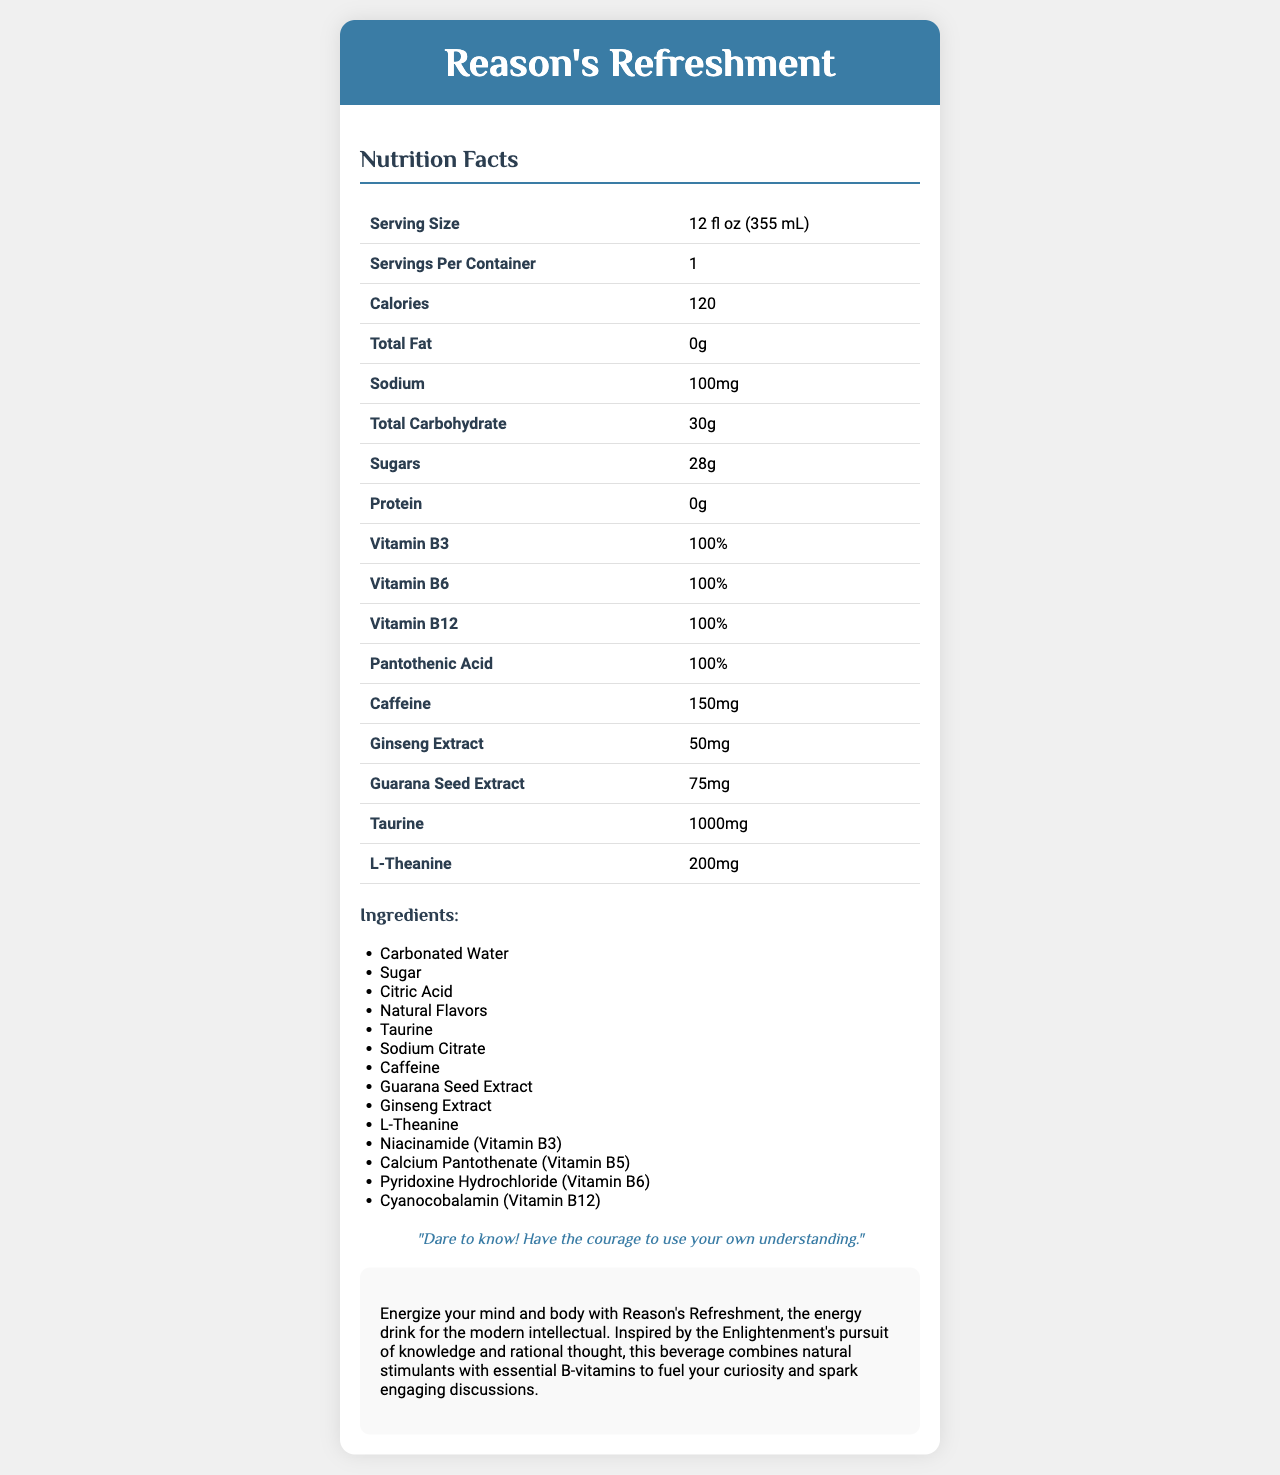what is the serving size for Reason's Refreshment? The serving size is stated in the Nutrition Facts section of the document.
Answer: 12 fl oz (355 mL) how many servings per container are there? The document lists servings per container as 1.
Answer: 1 how much sodium does Reason's Refreshment contain? According to the Nutrition Facts, Reason's Refreshment contains 100mg of sodium.
Answer: 100mg what is the amount of caffeine in the drink? The Nutrition Facts table specifies that there are 150mg of caffeine in the drink.
Answer: 150mg name all the B-vitamins present in the drink. The B-vitamins listed in the Nutrition Facts are Vitamin B3, Vitamin B6, Vitamin B12, and Pantothenic Acid.
Answer: Vitamin B3, Vitamin B6, Vitamin B12, Pantothenic Acid how much taurine is included in Reason's Refreshment? A. 500mg B. 1000mg C. 1500mg D. 2000mg The document states that Reason's Refreshment contains 1000mg of taurine.
Answer: B which ingredient is listed first in the ingredient list? A. Taurine B. Caffeine C. Carbonated Water D. Sugar The first ingredient listed is Carbonated Water.
Answer: C is there any protein in Reason's Refreshment? The Nutrition Facts section indicates that there is 0g of protein in the drink.
Answer: No what is the main idea of the philosophical blurb provided in the document? The blurb describes how Reason's Refreshment energizes both mind and body with natural stimulants and B-vitamins, inspired by the Enlightenment's values.
Answer: Energizing mind and body for intellectual pursuits how many grams of sugars are there per serving? The Nutrition Facts table specifies that there are 28g of sugars per serving.
Answer: 28g summarize the entire document. The document provides detailed nutritional information, a list of ingredients, and a philosophical blurb linking the drink to intellectual and rational pursuits.
Answer: Reason's Refreshment is an energy drink that combines natural stimulants and B-vitamins to support mental and physical performance. It contains 120 calories per 12 fl oz serving, and significant amounts of caffeine, taurine, and several B-vitamins. The document includes a detailed Nutrition Facts section, a list of ingredients, and a philosophical blurb inspired by the Enlightenment. what is the total amount of carbohydrates in the drink? The document states that the total carbohydrate content is 30g.
Answer: 30g how much ginseng extract is in each serving of Reason's Refreshment? The Nutrition Facts table specifies there are 50mg of ginseng extract.
Answer: 50mg how many ingredients are listed in the document? The ingredient list contains a total of 14 items.
Answer: 14 identify the quote included in the document. The document features an Enlightenment quote, "Dare to know! Have the courage to use your own understanding."
Answer: "Dare to know! Have the courage to use your own understanding." how much potassium does Reason's Refreshment contain? The document does not provide any information about the potassium content.
Answer: Not enough information 